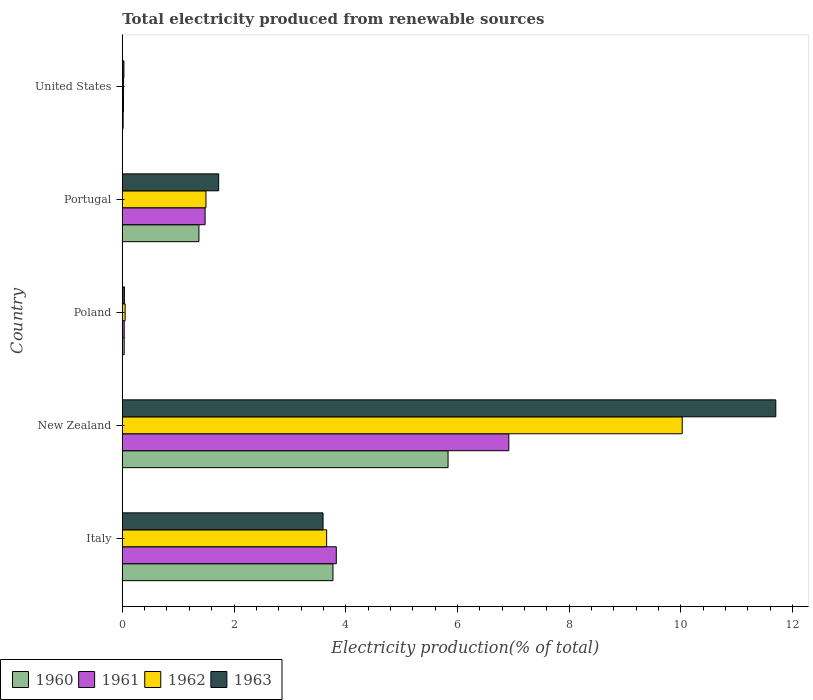How many different coloured bars are there?
Offer a terse response. 4. How many groups of bars are there?
Keep it short and to the point. 5. Are the number of bars per tick equal to the number of legend labels?
Provide a succinct answer. Yes. How many bars are there on the 3rd tick from the top?
Your answer should be very brief. 4. How many bars are there on the 2nd tick from the bottom?
Your answer should be compact. 4. In how many cases, is the number of bars for a given country not equal to the number of legend labels?
Offer a terse response. 0. What is the total electricity produced in 1962 in Italy?
Provide a short and direct response. 3.66. Across all countries, what is the maximum total electricity produced in 1962?
Your answer should be very brief. 10.02. Across all countries, what is the minimum total electricity produced in 1961?
Your response must be concise. 0.02. In which country was the total electricity produced in 1962 maximum?
Your answer should be very brief. New Zealand. In which country was the total electricity produced in 1960 minimum?
Make the answer very short. United States. What is the total total electricity produced in 1961 in the graph?
Your answer should be very brief. 12.29. What is the difference between the total electricity produced in 1962 in Italy and that in New Zealand?
Your answer should be compact. -6.37. What is the difference between the total electricity produced in 1960 in United States and the total electricity produced in 1961 in Italy?
Offer a very short reply. -3.82. What is the average total electricity produced in 1962 per country?
Offer a very short reply. 3.05. What is the difference between the total electricity produced in 1963 and total electricity produced in 1960 in Italy?
Your response must be concise. -0.18. What is the ratio of the total electricity produced in 1960 in Italy to that in Poland?
Offer a very short reply. 110.45. Is the total electricity produced in 1961 in Portugal less than that in United States?
Your answer should be compact. No. What is the difference between the highest and the second highest total electricity produced in 1963?
Give a very brief answer. 8.11. What is the difference between the highest and the lowest total electricity produced in 1963?
Offer a very short reply. 11.67. In how many countries, is the total electricity produced in 1960 greater than the average total electricity produced in 1960 taken over all countries?
Your answer should be compact. 2. Is it the case that in every country, the sum of the total electricity produced in 1961 and total electricity produced in 1963 is greater than the sum of total electricity produced in 1960 and total electricity produced in 1962?
Provide a short and direct response. No. How many bars are there?
Ensure brevity in your answer.  20. What is the difference between two consecutive major ticks on the X-axis?
Ensure brevity in your answer.  2. Are the values on the major ticks of X-axis written in scientific E-notation?
Your answer should be compact. No. Does the graph contain any zero values?
Provide a succinct answer. No. Does the graph contain grids?
Keep it short and to the point. No. Where does the legend appear in the graph?
Provide a short and direct response. Bottom left. How are the legend labels stacked?
Ensure brevity in your answer.  Horizontal. What is the title of the graph?
Keep it short and to the point. Total electricity produced from renewable sources. What is the label or title of the X-axis?
Provide a succinct answer. Electricity production(% of total). What is the label or title of the Y-axis?
Make the answer very short. Country. What is the Electricity production(% of total) of 1960 in Italy?
Ensure brevity in your answer.  3.77. What is the Electricity production(% of total) of 1961 in Italy?
Make the answer very short. 3.83. What is the Electricity production(% of total) in 1962 in Italy?
Keep it short and to the point. 3.66. What is the Electricity production(% of total) of 1963 in Italy?
Offer a terse response. 3.59. What is the Electricity production(% of total) in 1960 in New Zealand?
Your answer should be very brief. 5.83. What is the Electricity production(% of total) of 1961 in New Zealand?
Offer a very short reply. 6.92. What is the Electricity production(% of total) of 1962 in New Zealand?
Offer a very short reply. 10.02. What is the Electricity production(% of total) of 1963 in New Zealand?
Make the answer very short. 11.7. What is the Electricity production(% of total) of 1960 in Poland?
Ensure brevity in your answer.  0.03. What is the Electricity production(% of total) of 1961 in Poland?
Your answer should be compact. 0.03. What is the Electricity production(% of total) of 1962 in Poland?
Offer a very short reply. 0.05. What is the Electricity production(% of total) in 1963 in Poland?
Ensure brevity in your answer.  0.04. What is the Electricity production(% of total) of 1960 in Portugal?
Make the answer very short. 1.37. What is the Electricity production(% of total) of 1961 in Portugal?
Keep it short and to the point. 1.48. What is the Electricity production(% of total) in 1962 in Portugal?
Ensure brevity in your answer.  1.5. What is the Electricity production(% of total) of 1963 in Portugal?
Your answer should be compact. 1.73. What is the Electricity production(% of total) in 1960 in United States?
Ensure brevity in your answer.  0.02. What is the Electricity production(% of total) in 1961 in United States?
Your response must be concise. 0.02. What is the Electricity production(% of total) of 1962 in United States?
Keep it short and to the point. 0.02. What is the Electricity production(% of total) of 1963 in United States?
Provide a succinct answer. 0.03. Across all countries, what is the maximum Electricity production(% of total) in 1960?
Your response must be concise. 5.83. Across all countries, what is the maximum Electricity production(% of total) of 1961?
Provide a succinct answer. 6.92. Across all countries, what is the maximum Electricity production(% of total) of 1962?
Your response must be concise. 10.02. Across all countries, what is the maximum Electricity production(% of total) in 1963?
Provide a succinct answer. 11.7. Across all countries, what is the minimum Electricity production(% of total) in 1960?
Keep it short and to the point. 0.02. Across all countries, what is the minimum Electricity production(% of total) of 1961?
Your answer should be compact. 0.02. Across all countries, what is the minimum Electricity production(% of total) in 1962?
Offer a very short reply. 0.02. Across all countries, what is the minimum Electricity production(% of total) in 1963?
Provide a short and direct response. 0.03. What is the total Electricity production(% of total) in 1960 in the graph?
Your answer should be compact. 11.03. What is the total Electricity production(% of total) of 1961 in the graph?
Give a very brief answer. 12.29. What is the total Electricity production(% of total) of 1962 in the graph?
Provide a short and direct response. 15.25. What is the total Electricity production(% of total) of 1963 in the graph?
Your answer should be very brief. 17.09. What is the difference between the Electricity production(% of total) in 1960 in Italy and that in New Zealand?
Give a very brief answer. -2.06. What is the difference between the Electricity production(% of total) of 1961 in Italy and that in New Zealand?
Give a very brief answer. -3.09. What is the difference between the Electricity production(% of total) in 1962 in Italy and that in New Zealand?
Your answer should be compact. -6.37. What is the difference between the Electricity production(% of total) in 1963 in Italy and that in New Zealand?
Your answer should be compact. -8.11. What is the difference between the Electricity production(% of total) of 1960 in Italy and that in Poland?
Make the answer very short. 3.74. What is the difference between the Electricity production(% of total) in 1961 in Italy and that in Poland?
Your answer should be very brief. 3.8. What is the difference between the Electricity production(% of total) in 1962 in Italy and that in Poland?
Your answer should be very brief. 3.61. What is the difference between the Electricity production(% of total) of 1963 in Italy and that in Poland?
Your answer should be compact. 3.56. What is the difference between the Electricity production(% of total) of 1960 in Italy and that in Portugal?
Make the answer very short. 2.4. What is the difference between the Electricity production(% of total) in 1961 in Italy and that in Portugal?
Ensure brevity in your answer.  2.35. What is the difference between the Electricity production(% of total) of 1962 in Italy and that in Portugal?
Provide a succinct answer. 2.16. What is the difference between the Electricity production(% of total) of 1963 in Italy and that in Portugal?
Keep it short and to the point. 1.87. What is the difference between the Electricity production(% of total) of 1960 in Italy and that in United States?
Keep it short and to the point. 3.76. What is the difference between the Electricity production(% of total) of 1961 in Italy and that in United States?
Offer a very short reply. 3.81. What is the difference between the Electricity production(% of total) in 1962 in Italy and that in United States?
Provide a short and direct response. 3.64. What is the difference between the Electricity production(% of total) in 1963 in Italy and that in United States?
Ensure brevity in your answer.  3.56. What is the difference between the Electricity production(% of total) in 1960 in New Zealand and that in Poland?
Offer a very short reply. 5.8. What is the difference between the Electricity production(% of total) of 1961 in New Zealand and that in Poland?
Give a very brief answer. 6.89. What is the difference between the Electricity production(% of total) of 1962 in New Zealand and that in Poland?
Your response must be concise. 9.97. What is the difference between the Electricity production(% of total) of 1963 in New Zealand and that in Poland?
Offer a very short reply. 11.66. What is the difference between the Electricity production(% of total) in 1960 in New Zealand and that in Portugal?
Provide a succinct answer. 4.46. What is the difference between the Electricity production(% of total) in 1961 in New Zealand and that in Portugal?
Offer a very short reply. 5.44. What is the difference between the Electricity production(% of total) of 1962 in New Zealand and that in Portugal?
Keep it short and to the point. 8.53. What is the difference between the Electricity production(% of total) of 1963 in New Zealand and that in Portugal?
Offer a very short reply. 9.97. What is the difference between the Electricity production(% of total) in 1960 in New Zealand and that in United States?
Provide a succinct answer. 5.82. What is the difference between the Electricity production(% of total) of 1961 in New Zealand and that in United States?
Offer a very short reply. 6.9. What is the difference between the Electricity production(% of total) in 1962 in New Zealand and that in United States?
Offer a terse response. 10. What is the difference between the Electricity production(% of total) in 1963 in New Zealand and that in United States?
Provide a short and direct response. 11.67. What is the difference between the Electricity production(% of total) in 1960 in Poland and that in Portugal?
Ensure brevity in your answer.  -1.34. What is the difference between the Electricity production(% of total) of 1961 in Poland and that in Portugal?
Give a very brief answer. -1.45. What is the difference between the Electricity production(% of total) of 1962 in Poland and that in Portugal?
Your answer should be compact. -1.45. What is the difference between the Electricity production(% of total) in 1963 in Poland and that in Portugal?
Your answer should be compact. -1.69. What is the difference between the Electricity production(% of total) in 1960 in Poland and that in United States?
Your answer should be very brief. 0.02. What is the difference between the Electricity production(% of total) of 1961 in Poland and that in United States?
Your response must be concise. 0.01. What is the difference between the Electricity production(% of total) of 1962 in Poland and that in United States?
Provide a short and direct response. 0.03. What is the difference between the Electricity production(% of total) of 1963 in Poland and that in United States?
Ensure brevity in your answer.  0.01. What is the difference between the Electricity production(% of total) in 1960 in Portugal and that in United States?
Your response must be concise. 1.36. What is the difference between the Electricity production(% of total) in 1961 in Portugal and that in United States?
Your response must be concise. 1.46. What is the difference between the Electricity production(% of total) in 1962 in Portugal and that in United States?
Give a very brief answer. 1.48. What is the difference between the Electricity production(% of total) of 1963 in Portugal and that in United States?
Provide a short and direct response. 1.7. What is the difference between the Electricity production(% of total) of 1960 in Italy and the Electricity production(% of total) of 1961 in New Zealand?
Make the answer very short. -3.15. What is the difference between the Electricity production(% of total) of 1960 in Italy and the Electricity production(% of total) of 1962 in New Zealand?
Provide a succinct answer. -6.25. What is the difference between the Electricity production(% of total) in 1960 in Italy and the Electricity production(% of total) in 1963 in New Zealand?
Your response must be concise. -7.93. What is the difference between the Electricity production(% of total) of 1961 in Italy and the Electricity production(% of total) of 1962 in New Zealand?
Provide a short and direct response. -6.19. What is the difference between the Electricity production(% of total) in 1961 in Italy and the Electricity production(% of total) in 1963 in New Zealand?
Keep it short and to the point. -7.87. What is the difference between the Electricity production(% of total) in 1962 in Italy and the Electricity production(% of total) in 1963 in New Zealand?
Offer a very short reply. -8.04. What is the difference between the Electricity production(% of total) in 1960 in Italy and the Electricity production(% of total) in 1961 in Poland?
Make the answer very short. 3.74. What is the difference between the Electricity production(% of total) of 1960 in Italy and the Electricity production(% of total) of 1962 in Poland?
Your response must be concise. 3.72. What is the difference between the Electricity production(% of total) of 1960 in Italy and the Electricity production(% of total) of 1963 in Poland?
Provide a succinct answer. 3.73. What is the difference between the Electricity production(% of total) of 1961 in Italy and the Electricity production(% of total) of 1962 in Poland?
Offer a very short reply. 3.78. What is the difference between the Electricity production(% of total) of 1961 in Italy and the Electricity production(% of total) of 1963 in Poland?
Your answer should be very brief. 3.79. What is the difference between the Electricity production(% of total) in 1962 in Italy and the Electricity production(% of total) in 1963 in Poland?
Provide a short and direct response. 3.62. What is the difference between the Electricity production(% of total) of 1960 in Italy and the Electricity production(% of total) of 1961 in Portugal?
Keep it short and to the point. 2.29. What is the difference between the Electricity production(% of total) of 1960 in Italy and the Electricity production(% of total) of 1962 in Portugal?
Ensure brevity in your answer.  2.27. What is the difference between the Electricity production(% of total) of 1960 in Italy and the Electricity production(% of total) of 1963 in Portugal?
Your answer should be compact. 2.05. What is the difference between the Electricity production(% of total) of 1961 in Italy and the Electricity production(% of total) of 1962 in Portugal?
Offer a terse response. 2.33. What is the difference between the Electricity production(% of total) in 1961 in Italy and the Electricity production(% of total) in 1963 in Portugal?
Ensure brevity in your answer.  2.11. What is the difference between the Electricity production(% of total) in 1962 in Italy and the Electricity production(% of total) in 1963 in Portugal?
Keep it short and to the point. 1.93. What is the difference between the Electricity production(% of total) in 1960 in Italy and the Electricity production(% of total) in 1961 in United States?
Your response must be concise. 3.75. What is the difference between the Electricity production(% of total) in 1960 in Italy and the Electricity production(% of total) in 1962 in United States?
Provide a succinct answer. 3.75. What is the difference between the Electricity production(% of total) of 1960 in Italy and the Electricity production(% of total) of 1963 in United States?
Your response must be concise. 3.74. What is the difference between the Electricity production(% of total) of 1961 in Italy and the Electricity production(% of total) of 1962 in United States?
Offer a terse response. 3.81. What is the difference between the Electricity production(% of total) of 1961 in Italy and the Electricity production(% of total) of 1963 in United States?
Make the answer very short. 3.8. What is the difference between the Electricity production(% of total) in 1962 in Italy and the Electricity production(% of total) in 1963 in United States?
Your response must be concise. 3.63. What is the difference between the Electricity production(% of total) in 1960 in New Zealand and the Electricity production(% of total) in 1961 in Poland?
Your answer should be very brief. 5.8. What is the difference between the Electricity production(% of total) in 1960 in New Zealand and the Electricity production(% of total) in 1962 in Poland?
Give a very brief answer. 5.78. What is the difference between the Electricity production(% of total) in 1960 in New Zealand and the Electricity production(% of total) in 1963 in Poland?
Your response must be concise. 5.79. What is the difference between the Electricity production(% of total) of 1961 in New Zealand and the Electricity production(% of total) of 1962 in Poland?
Provide a short and direct response. 6.87. What is the difference between the Electricity production(% of total) in 1961 in New Zealand and the Electricity production(% of total) in 1963 in Poland?
Your answer should be very brief. 6.88. What is the difference between the Electricity production(% of total) of 1962 in New Zealand and the Electricity production(% of total) of 1963 in Poland?
Your answer should be very brief. 9.99. What is the difference between the Electricity production(% of total) of 1960 in New Zealand and the Electricity production(% of total) of 1961 in Portugal?
Make the answer very short. 4.35. What is the difference between the Electricity production(% of total) in 1960 in New Zealand and the Electricity production(% of total) in 1962 in Portugal?
Your answer should be compact. 4.33. What is the difference between the Electricity production(% of total) of 1960 in New Zealand and the Electricity production(% of total) of 1963 in Portugal?
Your response must be concise. 4.11. What is the difference between the Electricity production(% of total) of 1961 in New Zealand and the Electricity production(% of total) of 1962 in Portugal?
Provide a succinct answer. 5.42. What is the difference between the Electricity production(% of total) of 1961 in New Zealand and the Electricity production(% of total) of 1963 in Portugal?
Offer a very short reply. 5.19. What is the difference between the Electricity production(% of total) in 1962 in New Zealand and the Electricity production(% of total) in 1963 in Portugal?
Ensure brevity in your answer.  8.3. What is the difference between the Electricity production(% of total) of 1960 in New Zealand and the Electricity production(% of total) of 1961 in United States?
Provide a short and direct response. 5.81. What is the difference between the Electricity production(% of total) in 1960 in New Zealand and the Electricity production(% of total) in 1962 in United States?
Keep it short and to the point. 5.81. What is the difference between the Electricity production(% of total) of 1960 in New Zealand and the Electricity production(% of total) of 1963 in United States?
Provide a succinct answer. 5.8. What is the difference between the Electricity production(% of total) in 1961 in New Zealand and the Electricity production(% of total) in 1962 in United States?
Keep it short and to the point. 6.9. What is the difference between the Electricity production(% of total) in 1961 in New Zealand and the Electricity production(% of total) in 1963 in United States?
Your answer should be compact. 6.89. What is the difference between the Electricity production(% of total) of 1962 in New Zealand and the Electricity production(% of total) of 1963 in United States?
Provide a short and direct response. 10. What is the difference between the Electricity production(% of total) in 1960 in Poland and the Electricity production(% of total) in 1961 in Portugal?
Your answer should be compact. -1.45. What is the difference between the Electricity production(% of total) of 1960 in Poland and the Electricity production(% of total) of 1962 in Portugal?
Keep it short and to the point. -1.46. What is the difference between the Electricity production(% of total) of 1960 in Poland and the Electricity production(% of total) of 1963 in Portugal?
Make the answer very short. -1.69. What is the difference between the Electricity production(% of total) of 1961 in Poland and the Electricity production(% of total) of 1962 in Portugal?
Make the answer very short. -1.46. What is the difference between the Electricity production(% of total) in 1961 in Poland and the Electricity production(% of total) in 1963 in Portugal?
Your answer should be compact. -1.69. What is the difference between the Electricity production(% of total) in 1962 in Poland and the Electricity production(% of total) in 1963 in Portugal?
Provide a short and direct response. -1.67. What is the difference between the Electricity production(% of total) in 1960 in Poland and the Electricity production(% of total) in 1961 in United States?
Give a very brief answer. 0.01. What is the difference between the Electricity production(% of total) in 1960 in Poland and the Electricity production(% of total) in 1962 in United States?
Offer a very short reply. 0.01. What is the difference between the Electricity production(% of total) of 1960 in Poland and the Electricity production(% of total) of 1963 in United States?
Give a very brief answer. 0. What is the difference between the Electricity production(% of total) of 1961 in Poland and the Electricity production(% of total) of 1962 in United States?
Offer a terse response. 0.01. What is the difference between the Electricity production(% of total) in 1961 in Poland and the Electricity production(% of total) in 1963 in United States?
Provide a short and direct response. 0. What is the difference between the Electricity production(% of total) in 1962 in Poland and the Electricity production(% of total) in 1963 in United States?
Offer a terse response. 0.02. What is the difference between the Electricity production(% of total) in 1960 in Portugal and the Electricity production(% of total) in 1961 in United States?
Provide a succinct answer. 1.35. What is the difference between the Electricity production(% of total) in 1960 in Portugal and the Electricity production(% of total) in 1962 in United States?
Make the answer very short. 1.35. What is the difference between the Electricity production(% of total) of 1960 in Portugal and the Electricity production(% of total) of 1963 in United States?
Your answer should be very brief. 1.34. What is the difference between the Electricity production(% of total) in 1961 in Portugal and the Electricity production(% of total) in 1962 in United States?
Offer a very short reply. 1.46. What is the difference between the Electricity production(% of total) of 1961 in Portugal and the Electricity production(% of total) of 1963 in United States?
Your answer should be compact. 1.45. What is the difference between the Electricity production(% of total) of 1962 in Portugal and the Electricity production(% of total) of 1963 in United States?
Your response must be concise. 1.47. What is the average Electricity production(% of total) of 1960 per country?
Keep it short and to the point. 2.21. What is the average Electricity production(% of total) in 1961 per country?
Your answer should be very brief. 2.46. What is the average Electricity production(% of total) in 1962 per country?
Your answer should be compact. 3.05. What is the average Electricity production(% of total) in 1963 per country?
Provide a short and direct response. 3.42. What is the difference between the Electricity production(% of total) in 1960 and Electricity production(% of total) in 1961 in Italy?
Your answer should be very brief. -0.06. What is the difference between the Electricity production(% of total) of 1960 and Electricity production(% of total) of 1962 in Italy?
Provide a succinct answer. 0.11. What is the difference between the Electricity production(% of total) of 1960 and Electricity production(% of total) of 1963 in Italy?
Ensure brevity in your answer.  0.18. What is the difference between the Electricity production(% of total) in 1961 and Electricity production(% of total) in 1962 in Italy?
Your response must be concise. 0.17. What is the difference between the Electricity production(% of total) in 1961 and Electricity production(% of total) in 1963 in Italy?
Your response must be concise. 0.24. What is the difference between the Electricity production(% of total) of 1962 and Electricity production(% of total) of 1963 in Italy?
Offer a terse response. 0.06. What is the difference between the Electricity production(% of total) of 1960 and Electricity production(% of total) of 1961 in New Zealand?
Make the answer very short. -1.09. What is the difference between the Electricity production(% of total) in 1960 and Electricity production(% of total) in 1962 in New Zealand?
Your answer should be very brief. -4.19. What is the difference between the Electricity production(% of total) of 1960 and Electricity production(% of total) of 1963 in New Zealand?
Provide a short and direct response. -5.87. What is the difference between the Electricity production(% of total) of 1961 and Electricity production(% of total) of 1962 in New Zealand?
Your response must be concise. -3.1. What is the difference between the Electricity production(% of total) in 1961 and Electricity production(% of total) in 1963 in New Zealand?
Provide a short and direct response. -4.78. What is the difference between the Electricity production(% of total) in 1962 and Electricity production(% of total) in 1963 in New Zealand?
Give a very brief answer. -1.68. What is the difference between the Electricity production(% of total) in 1960 and Electricity production(% of total) in 1961 in Poland?
Make the answer very short. 0. What is the difference between the Electricity production(% of total) of 1960 and Electricity production(% of total) of 1962 in Poland?
Make the answer very short. -0.02. What is the difference between the Electricity production(% of total) in 1960 and Electricity production(% of total) in 1963 in Poland?
Give a very brief answer. -0. What is the difference between the Electricity production(% of total) of 1961 and Electricity production(% of total) of 1962 in Poland?
Offer a very short reply. -0.02. What is the difference between the Electricity production(% of total) of 1961 and Electricity production(% of total) of 1963 in Poland?
Offer a terse response. -0. What is the difference between the Electricity production(% of total) of 1962 and Electricity production(% of total) of 1963 in Poland?
Your response must be concise. 0.01. What is the difference between the Electricity production(% of total) of 1960 and Electricity production(% of total) of 1961 in Portugal?
Ensure brevity in your answer.  -0.11. What is the difference between the Electricity production(% of total) of 1960 and Electricity production(% of total) of 1962 in Portugal?
Your answer should be very brief. -0.13. What is the difference between the Electricity production(% of total) of 1960 and Electricity production(% of total) of 1963 in Portugal?
Keep it short and to the point. -0.35. What is the difference between the Electricity production(% of total) in 1961 and Electricity production(% of total) in 1962 in Portugal?
Give a very brief answer. -0.02. What is the difference between the Electricity production(% of total) of 1961 and Electricity production(% of total) of 1963 in Portugal?
Ensure brevity in your answer.  -0.24. What is the difference between the Electricity production(% of total) of 1962 and Electricity production(% of total) of 1963 in Portugal?
Make the answer very short. -0.23. What is the difference between the Electricity production(% of total) in 1960 and Electricity production(% of total) in 1961 in United States?
Make the answer very short. -0.01. What is the difference between the Electricity production(% of total) in 1960 and Electricity production(% of total) in 1962 in United States?
Offer a terse response. -0.01. What is the difference between the Electricity production(% of total) of 1960 and Electricity production(% of total) of 1963 in United States?
Give a very brief answer. -0.01. What is the difference between the Electricity production(% of total) of 1961 and Electricity production(% of total) of 1962 in United States?
Provide a succinct answer. -0. What is the difference between the Electricity production(% of total) in 1961 and Electricity production(% of total) in 1963 in United States?
Give a very brief answer. -0.01. What is the difference between the Electricity production(% of total) of 1962 and Electricity production(% of total) of 1963 in United States?
Your answer should be compact. -0.01. What is the ratio of the Electricity production(% of total) of 1960 in Italy to that in New Zealand?
Provide a short and direct response. 0.65. What is the ratio of the Electricity production(% of total) of 1961 in Italy to that in New Zealand?
Your response must be concise. 0.55. What is the ratio of the Electricity production(% of total) in 1962 in Italy to that in New Zealand?
Your answer should be compact. 0.36. What is the ratio of the Electricity production(% of total) in 1963 in Italy to that in New Zealand?
Give a very brief answer. 0.31. What is the ratio of the Electricity production(% of total) in 1960 in Italy to that in Poland?
Keep it short and to the point. 110.45. What is the ratio of the Electricity production(% of total) in 1961 in Italy to that in Poland?
Ensure brevity in your answer.  112.3. What is the ratio of the Electricity production(% of total) in 1962 in Italy to that in Poland?
Make the answer very short. 71.88. What is the ratio of the Electricity production(% of total) of 1963 in Italy to that in Poland?
Your answer should be very brief. 94.84. What is the ratio of the Electricity production(% of total) of 1960 in Italy to that in Portugal?
Ensure brevity in your answer.  2.75. What is the ratio of the Electricity production(% of total) of 1961 in Italy to that in Portugal?
Give a very brief answer. 2.58. What is the ratio of the Electricity production(% of total) in 1962 in Italy to that in Portugal?
Offer a very short reply. 2.44. What is the ratio of the Electricity production(% of total) of 1963 in Italy to that in Portugal?
Your answer should be compact. 2.08. What is the ratio of the Electricity production(% of total) of 1960 in Italy to that in United States?
Keep it short and to the point. 247.25. What is the ratio of the Electricity production(% of total) of 1961 in Italy to that in United States?
Offer a terse response. 177.87. What is the ratio of the Electricity production(% of total) of 1962 in Italy to that in United States?
Provide a succinct answer. 160.56. What is the ratio of the Electricity production(% of total) of 1963 in Italy to that in United States?
Your answer should be compact. 122.12. What is the ratio of the Electricity production(% of total) in 1960 in New Zealand to that in Poland?
Provide a succinct answer. 170.79. What is the ratio of the Electricity production(% of total) of 1961 in New Zealand to that in Poland?
Your answer should be very brief. 202.83. What is the ratio of the Electricity production(% of total) of 1962 in New Zealand to that in Poland?
Provide a succinct answer. 196.95. What is the ratio of the Electricity production(% of total) of 1963 in New Zealand to that in Poland?
Ensure brevity in your answer.  308.73. What is the ratio of the Electricity production(% of total) in 1960 in New Zealand to that in Portugal?
Keep it short and to the point. 4.25. What is the ratio of the Electricity production(% of total) in 1961 in New Zealand to that in Portugal?
Offer a very short reply. 4.67. What is the ratio of the Electricity production(% of total) of 1962 in New Zealand to that in Portugal?
Ensure brevity in your answer.  6.69. What is the ratio of the Electricity production(% of total) in 1963 in New Zealand to that in Portugal?
Keep it short and to the point. 6.78. What is the ratio of the Electricity production(% of total) in 1960 in New Zealand to that in United States?
Provide a succinct answer. 382.31. What is the ratio of the Electricity production(% of total) in 1961 in New Zealand to that in United States?
Keep it short and to the point. 321.25. What is the ratio of the Electricity production(% of total) in 1962 in New Zealand to that in United States?
Your answer should be compact. 439.93. What is the ratio of the Electricity production(% of total) in 1963 in New Zealand to that in United States?
Offer a very short reply. 397.5. What is the ratio of the Electricity production(% of total) of 1960 in Poland to that in Portugal?
Offer a very short reply. 0.02. What is the ratio of the Electricity production(% of total) in 1961 in Poland to that in Portugal?
Your response must be concise. 0.02. What is the ratio of the Electricity production(% of total) of 1962 in Poland to that in Portugal?
Ensure brevity in your answer.  0.03. What is the ratio of the Electricity production(% of total) in 1963 in Poland to that in Portugal?
Your answer should be compact. 0.02. What is the ratio of the Electricity production(% of total) of 1960 in Poland to that in United States?
Provide a succinct answer. 2.24. What is the ratio of the Electricity production(% of total) in 1961 in Poland to that in United States?
Offer a terse response. 1.58. What is the ratio of the Electricity production(% of total) of 1962 in Poland to that in United States?
Your answer should be very brief. 2.23. What is the ratio of the Electricity production(% of total) in 1963 in Poland to that in United States?
Provide a succinct answer. 1.29. What is the ratio of the Electricity production(% of total) of 1960 in Portugal to that in United States?
Give a very brief answer. 89.96. What is the ratio of the Electricity production(% of total) of 1961 in Portugal to that in United States?
Give a very brief answer. 68.83. What is the ratio of the Electricity production(% of total) in 1962 in Portugal to that in United States?
Ensure brevity in your answer.  65.74. What is the ratio of the Electricity production(% of total) in 1963 in Portugal to that in United States?
Your response must be concise. 58.63. What is the difference between the highest and the second highest Electricity production(% of total) of 1960?
Your answer should be compact. 2.06. What is the difference between the highest and the second highest Electricity production(% of total) in 1961?
Provide a short and direct response. 3.09. What is the difference between the highest and the second highest Electricity production(% of total) of 1962?
Your response must be concise. 6.37. What is the difference between the highest and the second highest Electricity production(% of total) of 1963?
Make the answer very short. 8.11. What is the difference between the highest and the lowest Electricity production(% of total) of 1960?
Your answer should be compact. 5.82. What is the difference between the highest and the lowest Electricity production(% of total) of 1961?
Your answer should be very brief. 6.9. What is the difference between the highest and the lowest Electricity production(% of total) of 1962?
Keep it short and to the point. 10. What is the difference between the highest and the lowest Electricity production(% of total) in 1963?
Provide a succinct answer. 11.67. 